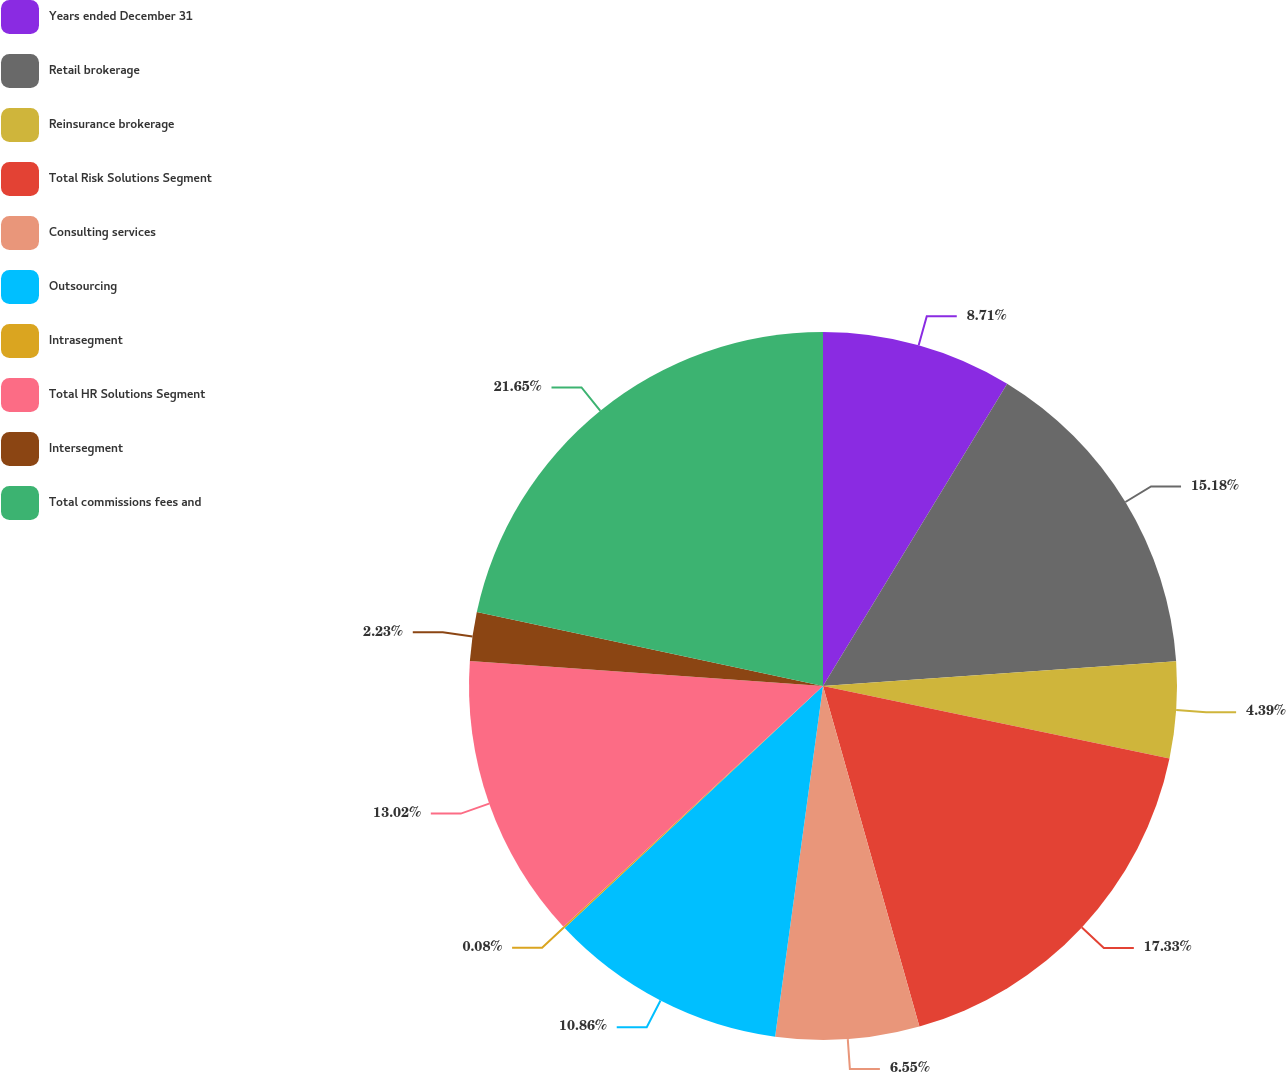Convert chart to OTSL. <chart><loc_0><loc_0><loc_500><loc_500><pie_chart><fcel>Years ended December 31<fcel>Retail brokerage<fcel>Reinsurance brokerage<fcel>Total Risk Solutions Segment<fcel>Consulting services<fcel>Outsourcing<fcel>Intrasegment<fcel>Total HR Solutions Segment<fcel>Intersegment<fcel>Total commissions fees and<nl><fcel>8.71%<fcel>15.18%<fcel>4.39%<fcel>17.33%<fcel>6.55%<fcel>10.86%<fcel>0.08%<fcel>13.02%<fcel>2.23%<fcel>21.65%<nl></chart> 